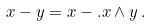Convert formula to latex. <formula><loc_0><loc_0><loc_500><loc_500>x - y = x - . x \wedge y \, .</formula> 